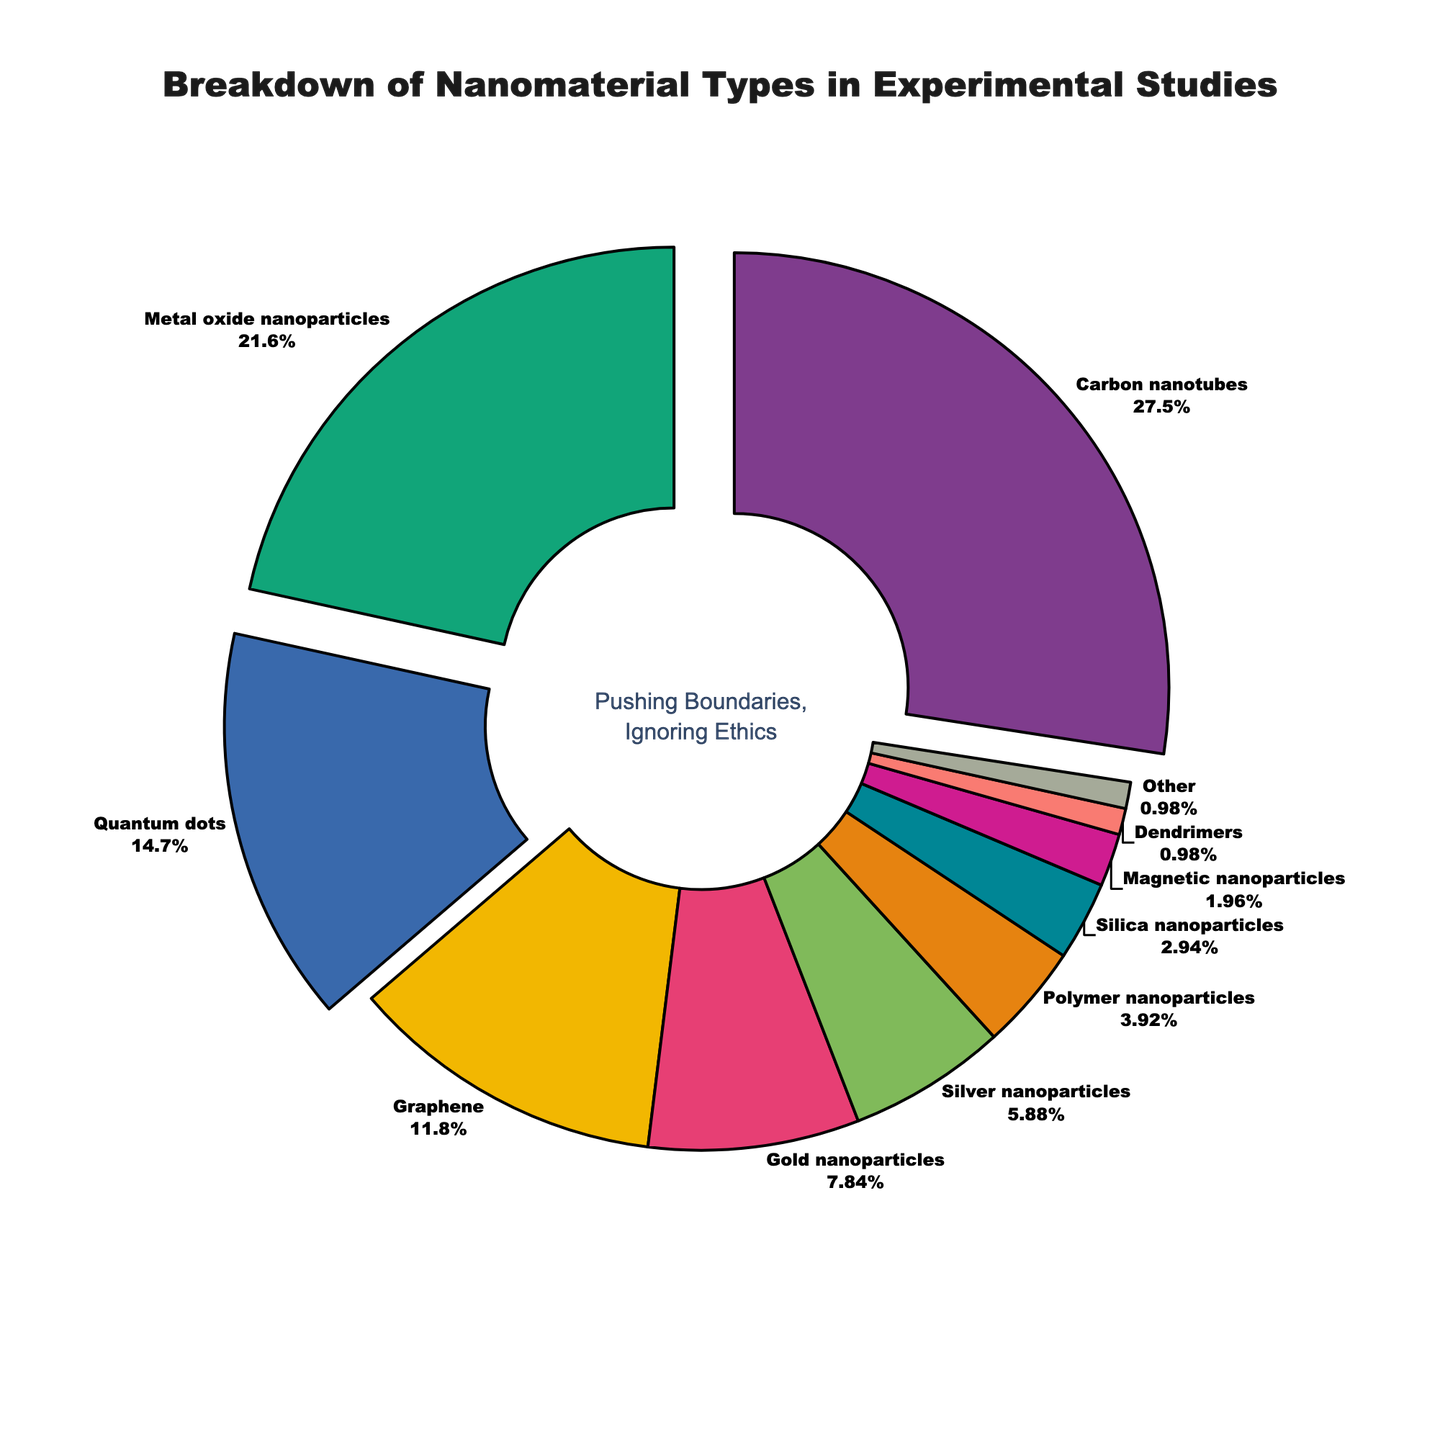Which nanomaterial type is the most used in experimental studies? Carbon nanotubes have the highest percentage on the pie chart, with 28%. This indicates they are the most used nanomaterial type.
Answer: Carbon nanotubes What is the combined percentage of Carbon nanotubes and Metal oxide nanoparticles? From the pie chart, Carbon nanotubes are 28% and Metal oxide nanoparticles are 22%. Adding these together, 28% + 22% = 50%.
Answer: 50% Which nanomaterial type has a slightly larger percentage: Graphene or Gold nanoparticles? Graphene has 12% and Gold nanoparticles have 8%. Graphene's percentage is slightly larger.
Answer: Graphene How much more prevalent are Silver nanoparticles compared to Dendrimers? Silver nanoparticles have 6% and Dendrimers have 1%. The difference is 6% - 1% = 5%.
Answer: 5% How many nanomaterial types have a percentage lower than 5%? From the chart, the nanomaterial types with less than 5% are Polymer nanoparticles (4%), Silica nanoparticles (3%), Magnetic nanoparticles (2%), Dendrimers (1%), and Other (1%). Thus, there are 5 types in total.
Answer: 5 What percentage of nanomaterials are in the "Other" category? "Other" is displayed on the pie chart as having 1%.
Answer: 1% Is the percentage of Quantum dots higher or lower than the percentage of Graphene? By how much? Quantum dots have 15% and Graphene has 12%. Quantum dots have 3% more than Graphene.
Answer: Higher by 3% What is the total percentage of the three least used nanomaterial types? The three least used nanomaterial types are Dendrimers (1%), Other (1%), and Magnetic nanoparticles (2%). Adding these, 1% + 1% + 2% = 4%.
Answer: 4% What is the combined percentage of Gold nanoparticles, Silver nanoparticles, and Polymer nanoparticles? The percentages are Gold nanoparticles (8%), Silver nanoparticles (6%), and Polymer nanoparticles (4%). Adding them together, 8% + 6% + 4% = 18%.
Answer: 18% What segment in the chart has the darkest shade? Carbon nanotubes have the darkest color used in the pie chart, as it's the most prominent sector.
Answer: Carbon nanotubes 